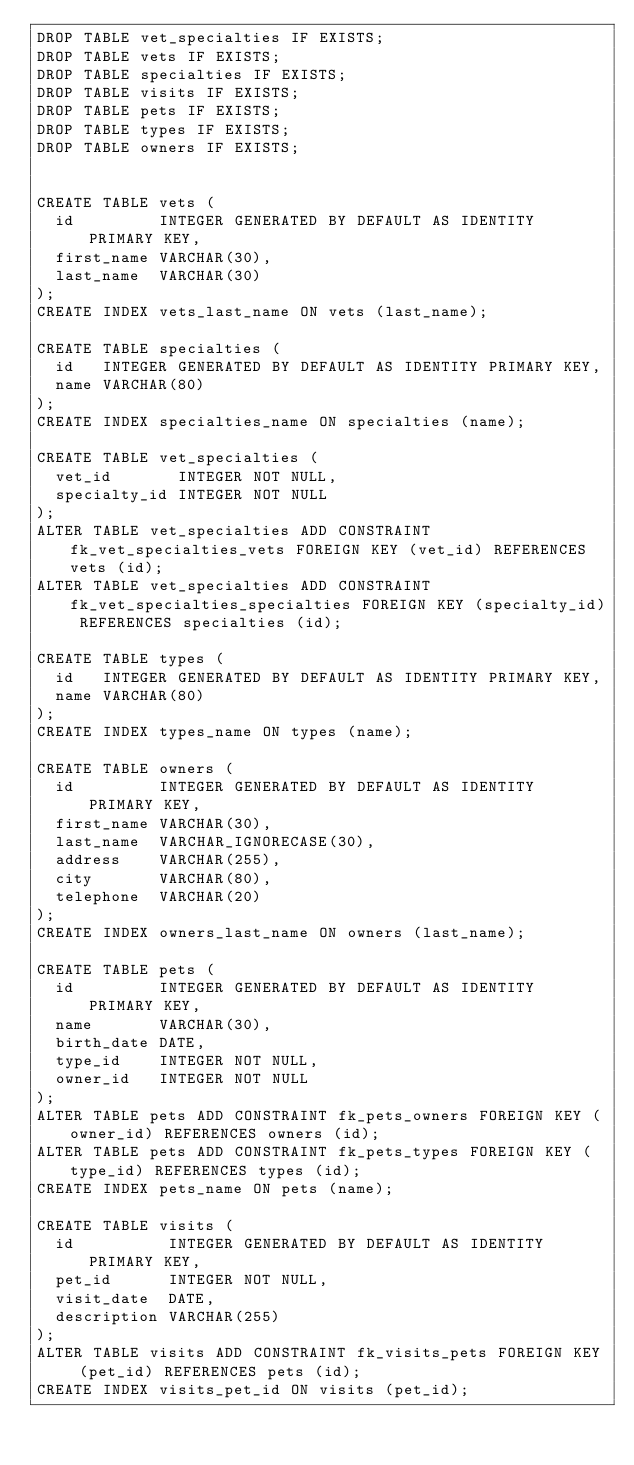<code> <loc_0><loc_0><loc_500><loc_500><_SQL_>DROP TABLE vet_specialties IF EXISTS;
DROP TABLE vets IF EXISTS;
DROP TABLE specialties IF EXISTS;
DROP TABLE visits IF EXISTS;
DROP TABLE pets IF EXISTS;
DROP TABLE types IF EXISTS;
DROP TABLE owners IF EXISTS;


CREATE TABLE vets (
  id         INTEGER GENERATED BY DEFAULT AS IDENTITY PRIMARY KEY,
  first_name VARCHAR(30),
  last_name  VARCHAR(30)
);
CREATE INDEX vets_last_name ON vets (last_name);

CREATE TABLE specialties (
  id   INTEGER GENERATED BY DEFAULT AS IDENTITY PRIMARY KEY,
  name VARCHAR(80)
);
CREATE INDEX specialties_name ON specialties (name);

CREATE TABLE vet_specialties (
  vet_id       INTEGER NOT NULL,
  specialty_id INTEGER NOT NULL
);
ALTER TABLE vet_specialties ADD CONSTRAINT fk_vet_specialties_vets FOREIGN KEY (vet_id) REFERENCES vets (id);
ALTER TABLE vet_specialties ADD CONSTRAINT fk_vet_specialties_specialties FOREIGN KEY (specialty_id) REFERENCES specialties (id);

CREATE TABLE types (
  id   INTEGER GENERATED BY DEFAULT AS IDENTITY PRIMARY KEY,
  name VARCHAR(80)
);
CREATE INDEX types_name ON types (name);

CREATE TABLE owners (
  id         INTEGER GENERATED BY DEFAULT AS IDENTITY PRIMARY KEY,
  first_name VARCHAR(30),
  last_name  VARCHAR_IGNORECASE(30),
  address    VARCHAR(255),
  city       VARCHAR(80),
  telephone  VARCHAR(20)
);
CREATE INDEX owners_last_name ON owners (last_name);

CREATE TABLE pets (
  id         INTEGER GENERATED BY DEFAULT AS IDENTITY PRIMARY KEY,
  name       VARCHAR(30),
  birth_date DATE,
  type_id    INTEGER NOT NULL,
  owner_id   INTEGER NOT NULL
);
ALTER TABLE pets ADD CONSTRAINT fk_pets_owners FOREIGN KEY (owner_id) REFERENCES owners (id);
ALTER TABLE pets ADD CONSTRAINT fk_pets_types FOREIGN KEY (type_id) REFERENCES types (id);
CREATE INDEX pets_name ON pets (name);

CREATE TABLE visits (
  id          INTEGER GENERATED BY DEFAULT AS IDENTITY PRIMARY KEY,
  pet_id      INTEGER NOT NULL,
  visit_date  DATE,
  description VARCHAR(255)
);
ALTER TABLE visits ADD CONSTRAINT fk_visits_pets FOREIGN KEY (pet_id) REFERENCES pets (id);
CREATE INDEX visits_pet_id ON visits (pet_id);
</code> 